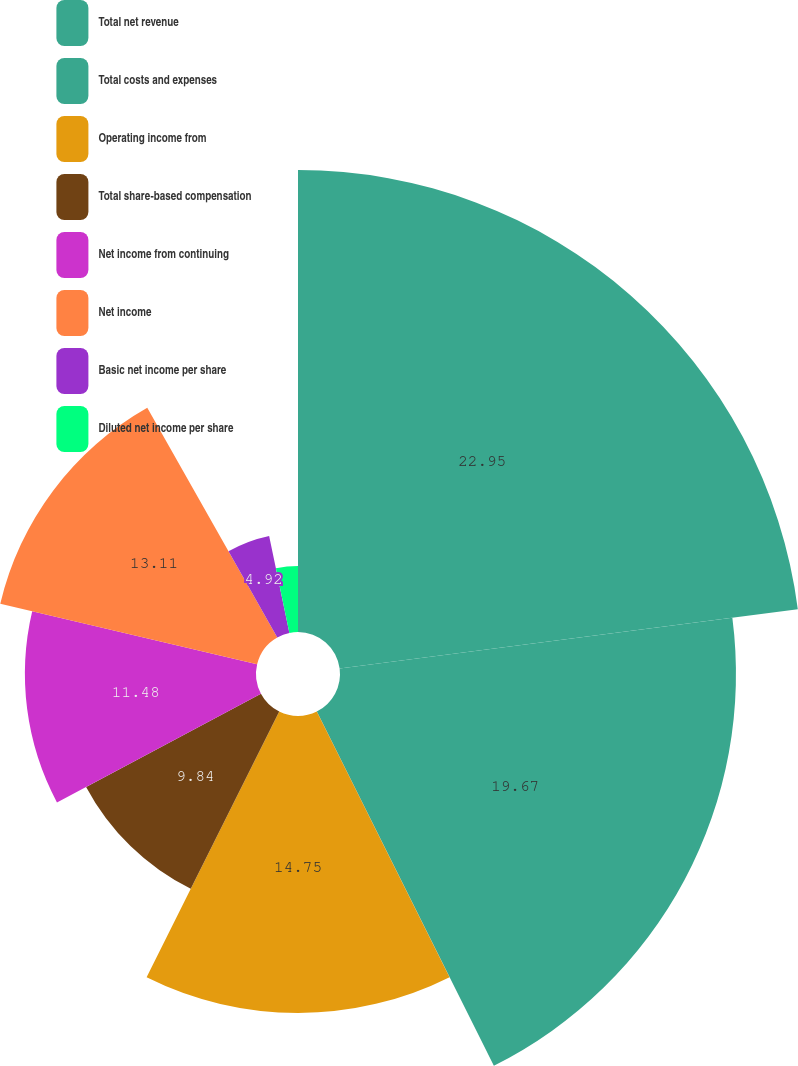<chart> <loc_0><loc_0><loc_500><loc_500><pie_chart><fcel>Total net revenue<fcel>Total costs and expenses<fcel>Operating income from<fcel>Total share-based compensation<fcel>Net income from continuing<fcel>Net income<fcel>Basic net income per share<fcel>Diluted net income per share<nl><fcel>22.95%<fcel>19.67%<fcel>14.75%<fcel>9.84%<fcel>11.48%<fcel>13.11%<fcel>4.92%<fcel>3.28%<nl></chart> 